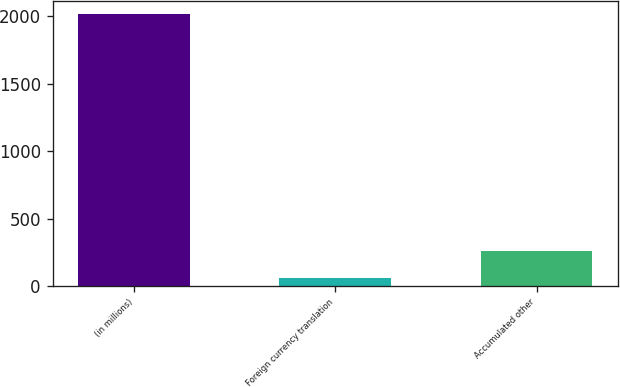Convert chart to OTSL. <chart><loc_0><loc_0><loc_500><loc_500><bar_chart><fcel>(in millions)<fcel>Foreign currency translation<fcel>Accumulated other<nl><fcel>2015<fcel>61.1<fcel>256.49<nl></chart> 